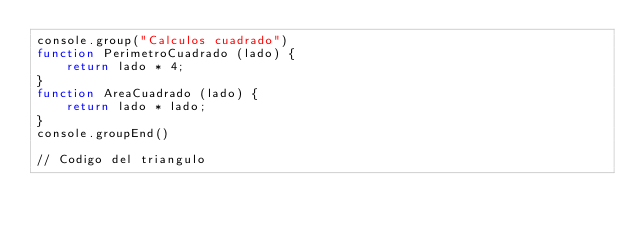Convert code to text. <code><loc_0><loc_0><loc_500><loc_500><_JavaScript_>console.group("Calculos cuadrado")
function PerimetroCuadrado (lado) {
    return lado * 4;
}
function AreaCuadrado (lado) {
    return lado * lado;
}
console.groupEnd()

// Codigo del triangulo</code> 